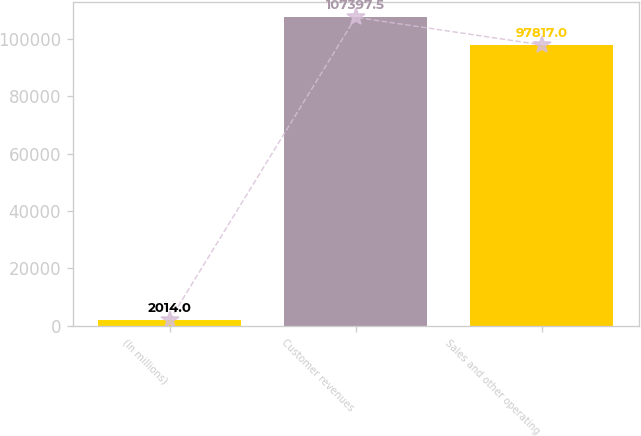Convert chart. <chart><loc_0><loc_0><loc_500><loc_500><bar_chart><fcel>(In millions)<fcel>Customer revenues<fcel>Sales and other operating<nl><fcel>2014<fcel>107398<fcel>97817<nl></chart> 